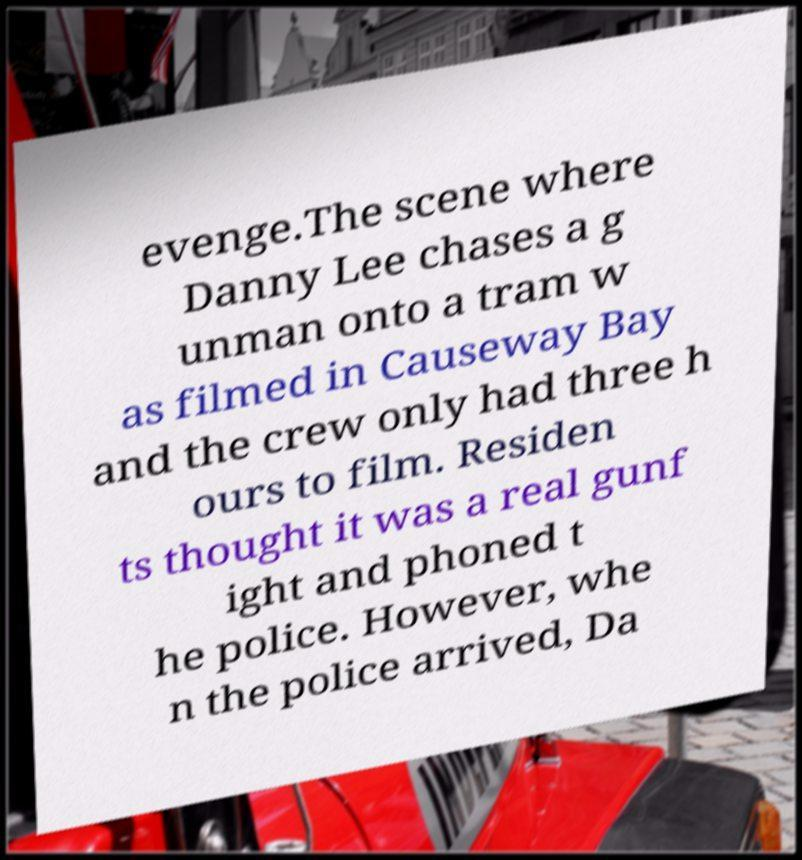I need the written content from this picture converted into text. Can you do that? evenge.The scene where Danny Lee chases a g unman onto a tram w as filmed in Causeway Bay and the crew only had three h ours to film. Residen ts thought it was a real gunf ight and phoned t he police. However, whe n the police arrived, Da 